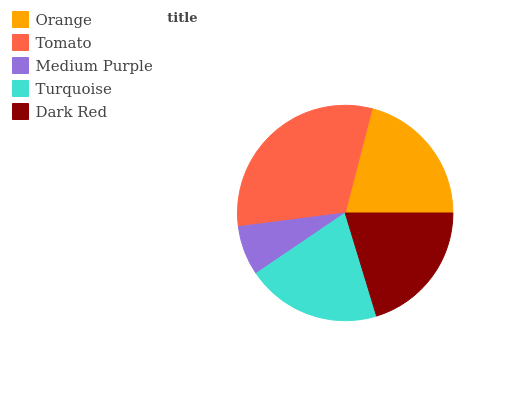Is Medium Purple the minimum?
Answer yes or no. Yes. Is Tomato the maximum?
Answer yes or no. Yes. Is Tomato the minimum?
Answer yes or no. No. Is Medium Purple the maximum?
Answer yes or no. No. Is Tomato greater than Medium Purple?
Answer yes or no. Yes. Is Medium Purple less than Tomato?
Answer yes or no. Yes. Is Medium Purple greater than Tomato?
Answer yes or no. No. Is Tomato less than Medium Purple?
Answer yes or no. No. Is Dark Red the high median?
Answer yes or no. Yes. Is Dark Red the low median?
Answer yes or no. Yes. Is Medium Purple the high median?
Answer yes or no. No. Is Tomato the low median?
Answer yes or no. No. 